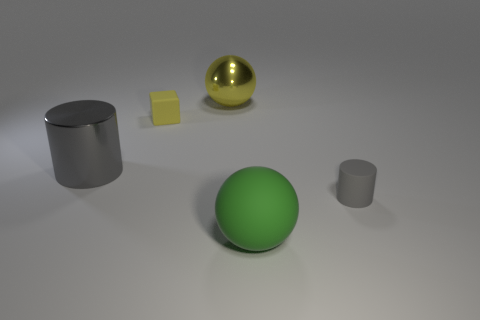Is the small rubber cylinder the same color as the large cylinder?
Make the answer very short. Yes. Are there any yellow things of the same size as the rubber cylinder?
Your response must be concise. Yes. There is a gray object that is to the right of the cube; does it have the same size as the matte cube?
Offer a terse response. Yes. How big is the gray rubber cylinder?
Provide a succinct answer. Small. What color is the big object that is in front of the cylinder that is in front of the object that is to the left of the tiny yellow matte thing?
Keep it short and to the point. Green. Is the color of the tiny matte object that is to the right of the green matte thing the same as the big cylinder?
Keep it short and to the point. Yes. What number of things are on the left side of the cube and right of the metal ball?
Give a very brief answer. 0. What is the size of the other gray rubber thing that is the same shape as the large gray object?
Give a very brief answer. Small. What number of big yellow things are right of the big shiny object that is to the right of the gray object that is left of the rubber cylinder?
Ensure brevity in your answer.  0. There is a large shiny thing that is in front of the big sphere behind the big metallic cylinder; what is its color?
Offer a very short reply. Gray. 